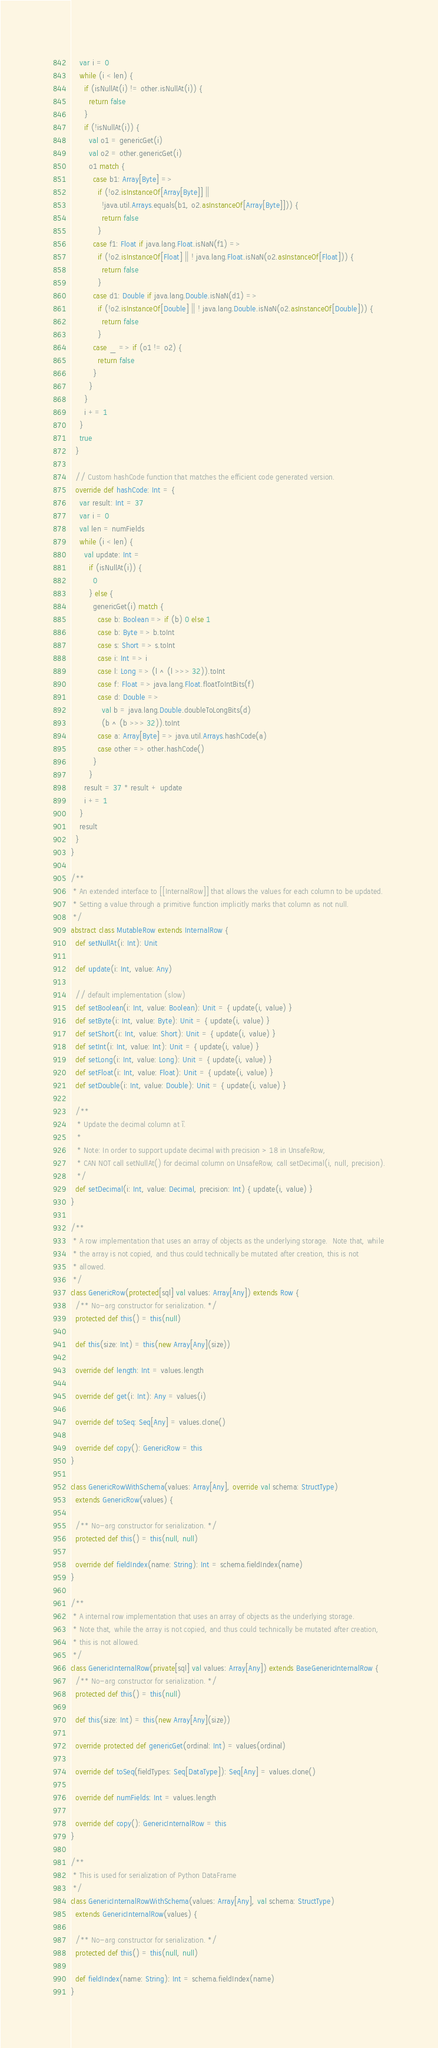Convert code to text. <code><loc_0><loc_0><loc_500><loc_500><_Scala_>    var i = 0
    while (i < len) {
      if (isNullAt(i) != other.isNullAt(i)) {
        return false
      }
      if (!isNullAt(i)) {
        val o1 = genericGet(i)
        val o2 = other.genericGet(i)
        o1 match {
          case b1: Array[Byte] =>
            if (!o2.isInstanceOf[Array[Byte]] ||
              !java.util.Arrays.equals(b1, o2.asInstanceOf[Array[Byte]])) {
              return false
            }
          case f1: Float if java.lang.Float.isNaN(f1) =>
            if (!o2.isInstanceOf[Float] || ! java.lang.Float.isNaN(o2.asInstanceOf[Float])) {
              return false
            }
          case d1: Double if java.lang.Double.isNaN(d1) =>
            if (!o2.isInstanceOf[Double] || ! java.lang.Double.isNaN(o2.asInstanceOf[Double])) {
              return false
            }
          case _ => if (o1 != o2) {
            return false
          }
        }
      }
      i += 1
    }
    true
  }

  // Custom hashCode function that matches the efficient code generated version.
  override def hashCode: Int = {
    var result: Int = 37
    var i = 0
    val len = numFields
    while (i < len) {
      val update: Int =
        if (isNullAt(i)) {
          0
        } else {
          genericGet(i) match {
            case b: Boolean => if (b) 0 else 1
            case b: Byte => b.toInt
            case s: Short => s.toInt
            case i: Int => i
            case l: Long => (l ^ (l >>> 32)).toInt
            case f: Float => java.lang.Float.floatToIntBits(f)
            case d: Double =>
              val b = java.lang.Double.doubleToLongBits(d)
              (b ^ (b >>> 32)).toInt
            case a: Array[Byte] => java.util.Arrays.hashCode(a)
            case other => other.hashCode()
          }
        }
      result = 37 * result + update
      i += 1
    }
    result
  }
}

/**
 * An extended interface to [[InternalRow]] that allows the values for each column to be updated.
 * Setting a value through a primitive function implicitly marks that column as not null.
 */
abstract class MutableRow extends InternalRow {
  def setNullAt(i: Int): Unit

  def update(i: Int, value: Any)

  // default implementation (slow)
  def setBoolean(i: Int, value: Boolean): Unit = { update(i, value) }
  def setByte(i: Int, value: Byte): Unit = { update(i, value) }
  def setShort(i: Int, value: Short): Unit = { update(i, value) }
  def setInt(i: Int, value: Int): Unit = { update(i, value) }
  def setLong(i: Int, value: Long): Unit = { update(i, value) }
  def setFloat(i: Int, value: Float): Unit = { update(i, value) }
  def setDouble(i: Int, value: Double): Unit = { update(i, value) }

  /**
   * Update the decimal column at `i`.
   *
   * Note: In order to support update decimal with precision > 18 in UnsafeRow,
   * CAN NOT call setNullAt() for decimal column on UnsafeRow, call setDecimal(i, null, precision).
   */
  def setDecimal(i: Int, value: Decimal, precision: Int) { update(i, value) }
}

/**
 * A row implementation that uses an array of objects as the underlying storage.  Note that, while
 * the array is not copied, and thus could technically be mutated after creation, this is not
 * allowed.
 */
class GenericRow(protected[sql] val values: Array[Any]) extends Row {
  /** No-arg constructor for serialization. */
  protected def this() = this(null)

  def this(size: Int) = this(new Array[Any](size))

  override def length: Int = values.length

  override def get(i: Int): Any = values(i)

  override def toSeq: Seq[Any] = values.clone()

  override def copy(): GenericRow = this
}

class GenericRowWithSchema(values: Array[Any], override val schema: StructType)
  extends GenericRow(values) {

  /** No-arg constructor for serialization. */
  protected def this() = this(null, null)

  override def fieldIndex(name: String): Int = schema.fieldIndex(name)
}

/**
 * A internal row implementation that uses an array of objects as the underlying storage.
 * Note that, while the array is not copied, and thus could technically be mutated after creation,
 * this is not allowed.
 */
class GenericInternalRow(private[sql] val values: Array[Any]) extends BaseGenericInternalRow {
  /** No-arg constructor for serialization. */
  protected def this() = this(null)

  def this(size: Int) = this(new Array[Any](size))

  override protected def genericGet(ordinal: Int) = values(ordinal)

  override def toSeq(fieldTypes: Seq[DataType]): Seq[Any] = values.clone()

  override def numFields: Int = values.length

  override def copy(): GenericInternalRow = this
}

/**
 * This is used for serialization of Python DataFrame
 */
class GenericInternalRowWithSchema(values: Array[Any], val schema: StructType)
  extends GenericInternalRow(values) {

  /** No-arg constructor for serialization. */
  protected def this() = this(null, null)

  def fieldIndex(name: String): Int = schema.fieldIndex(name)
}
</code> 